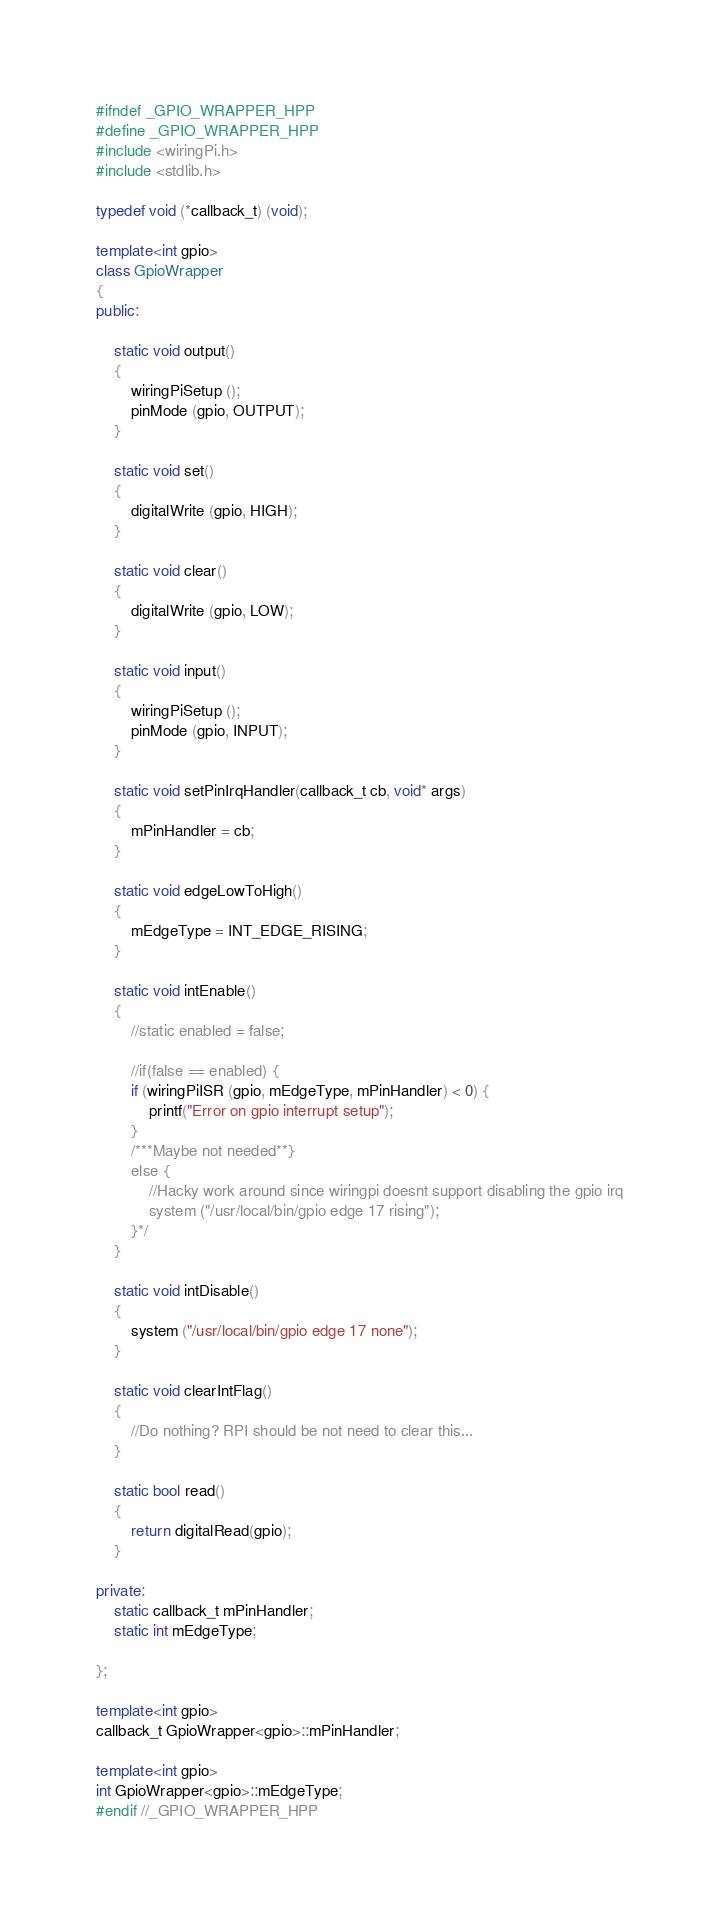<code> <loc_0><loc_0><loc_500><loc_500><_C++_>#ifndef _GPIO_WRAPPER_HPP
#define _GPIO_WRAPPER_HPP
#include <wiringPi.h>
#include <stdlib.h>

typedef void (*callback_t) (void);

template<int gpio>
class GpioWrapper
{
public:

	static void output()
	{
		wiringPiSetup ();
		pinMode (gpio, OUTPUT);
	}
	
	static void set()
	{
		digitalWrite (gpio, HIGH);
	}
	
	static void clear()
	{
		digitalWrite (gpio, LOW);
	}
	
	static void input()
	{
		wiringPiSetup ();
		pinMode (gpio, INPUT);
	}
	
	static void setPinIrqHandler(callback_t cb, void* args)
	{
		mPinHandler = cb;
	}
	
	static void edgeLowToHigh() 
	{
		mEdgeType = INT_EDGE_RISING;
	}
	
	static void intEnable()
	{
		//static enabled = false;
		
		//if(false == enabled) {
		if (wiringPiISR (gpio, mEdgeType, mPinHandler) < 0) {
			printf("Error on gpio interrupt setup");
    	}
    	/***Maybe not needed**}
    	else {
    		//Hacky work around since wiringpi doesnt support disabling the gpio irq
    		system ("/usr/local/bin/gpio edge 17 rising");
    	}*/
	}
	
	static void intDisable()
	{
		system ("/usr/local/bin/gpio edge 17 none");
	}
	
	static void clearIntFlag()
	{
		//Do nothing? RPI should be not need to clear this...
	}
	
	static bool read()
	{
		return digitalRead(gpio);
	}
	
private:
	static callback_t mPinHandler;
	static int mEdgeType;
	
};

template<int gpio>
callback_t GpioWrapper<gpio>::mPinHandler;

template<int gpio>
int GpioWrapper<gpio>::mEdgeType;
#endif //_GPIO_WRAPPER_HPP
</code> 